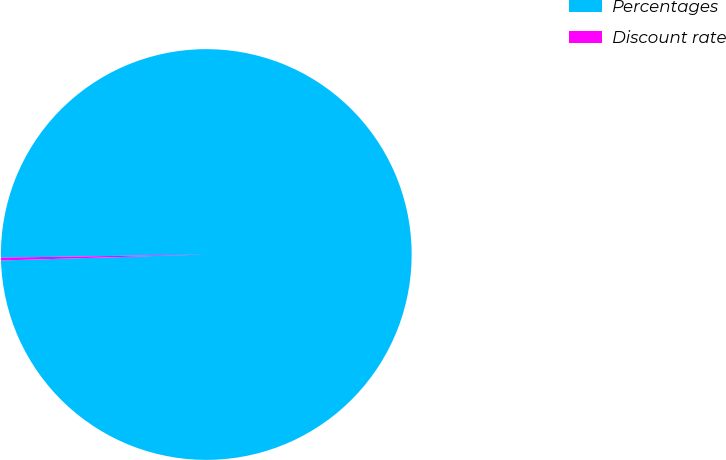Convert chart. <chart><loc_0><loc_0><loc_500><loc_500><pie_chart><fcel>Percentages<fcel>Discount rate<nl><fcel>99.78%<fcel>0.22%<nl></chart> 